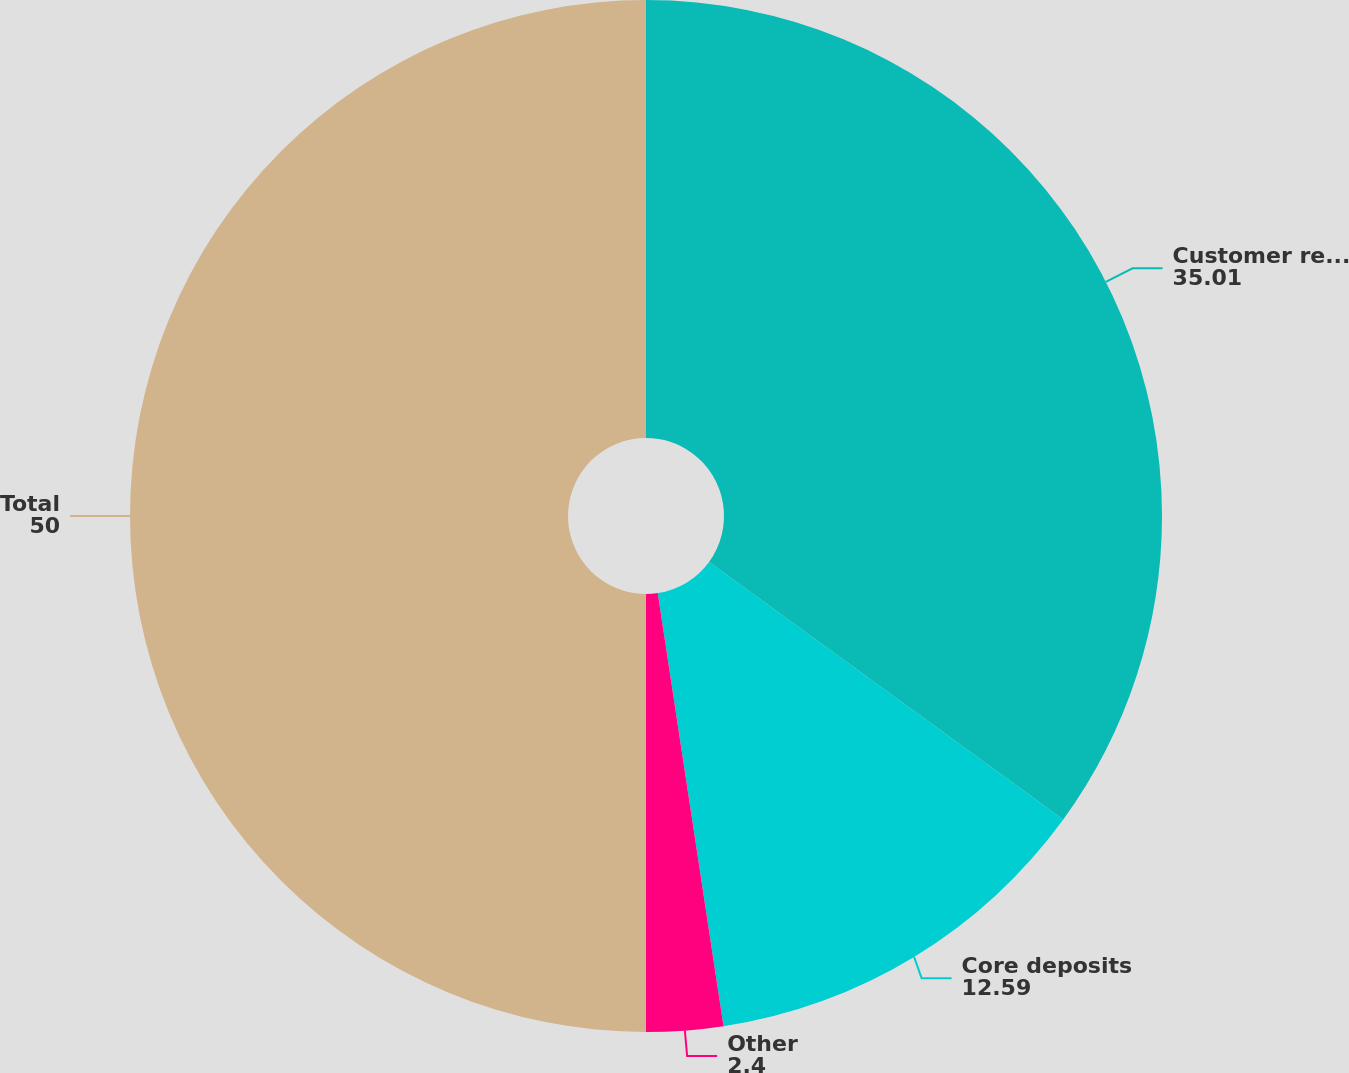Convert chart. <chart><loc_0><loc_0><loc_500><loc_500><pie_chart><fcel>Customer relationships<fcel>Core deposits<fcel>Other<fcel>Total<nl><fcel>35.01%<fcel>12.59%<fcel>2.4%<fcel>50.0%<nl></chart> 